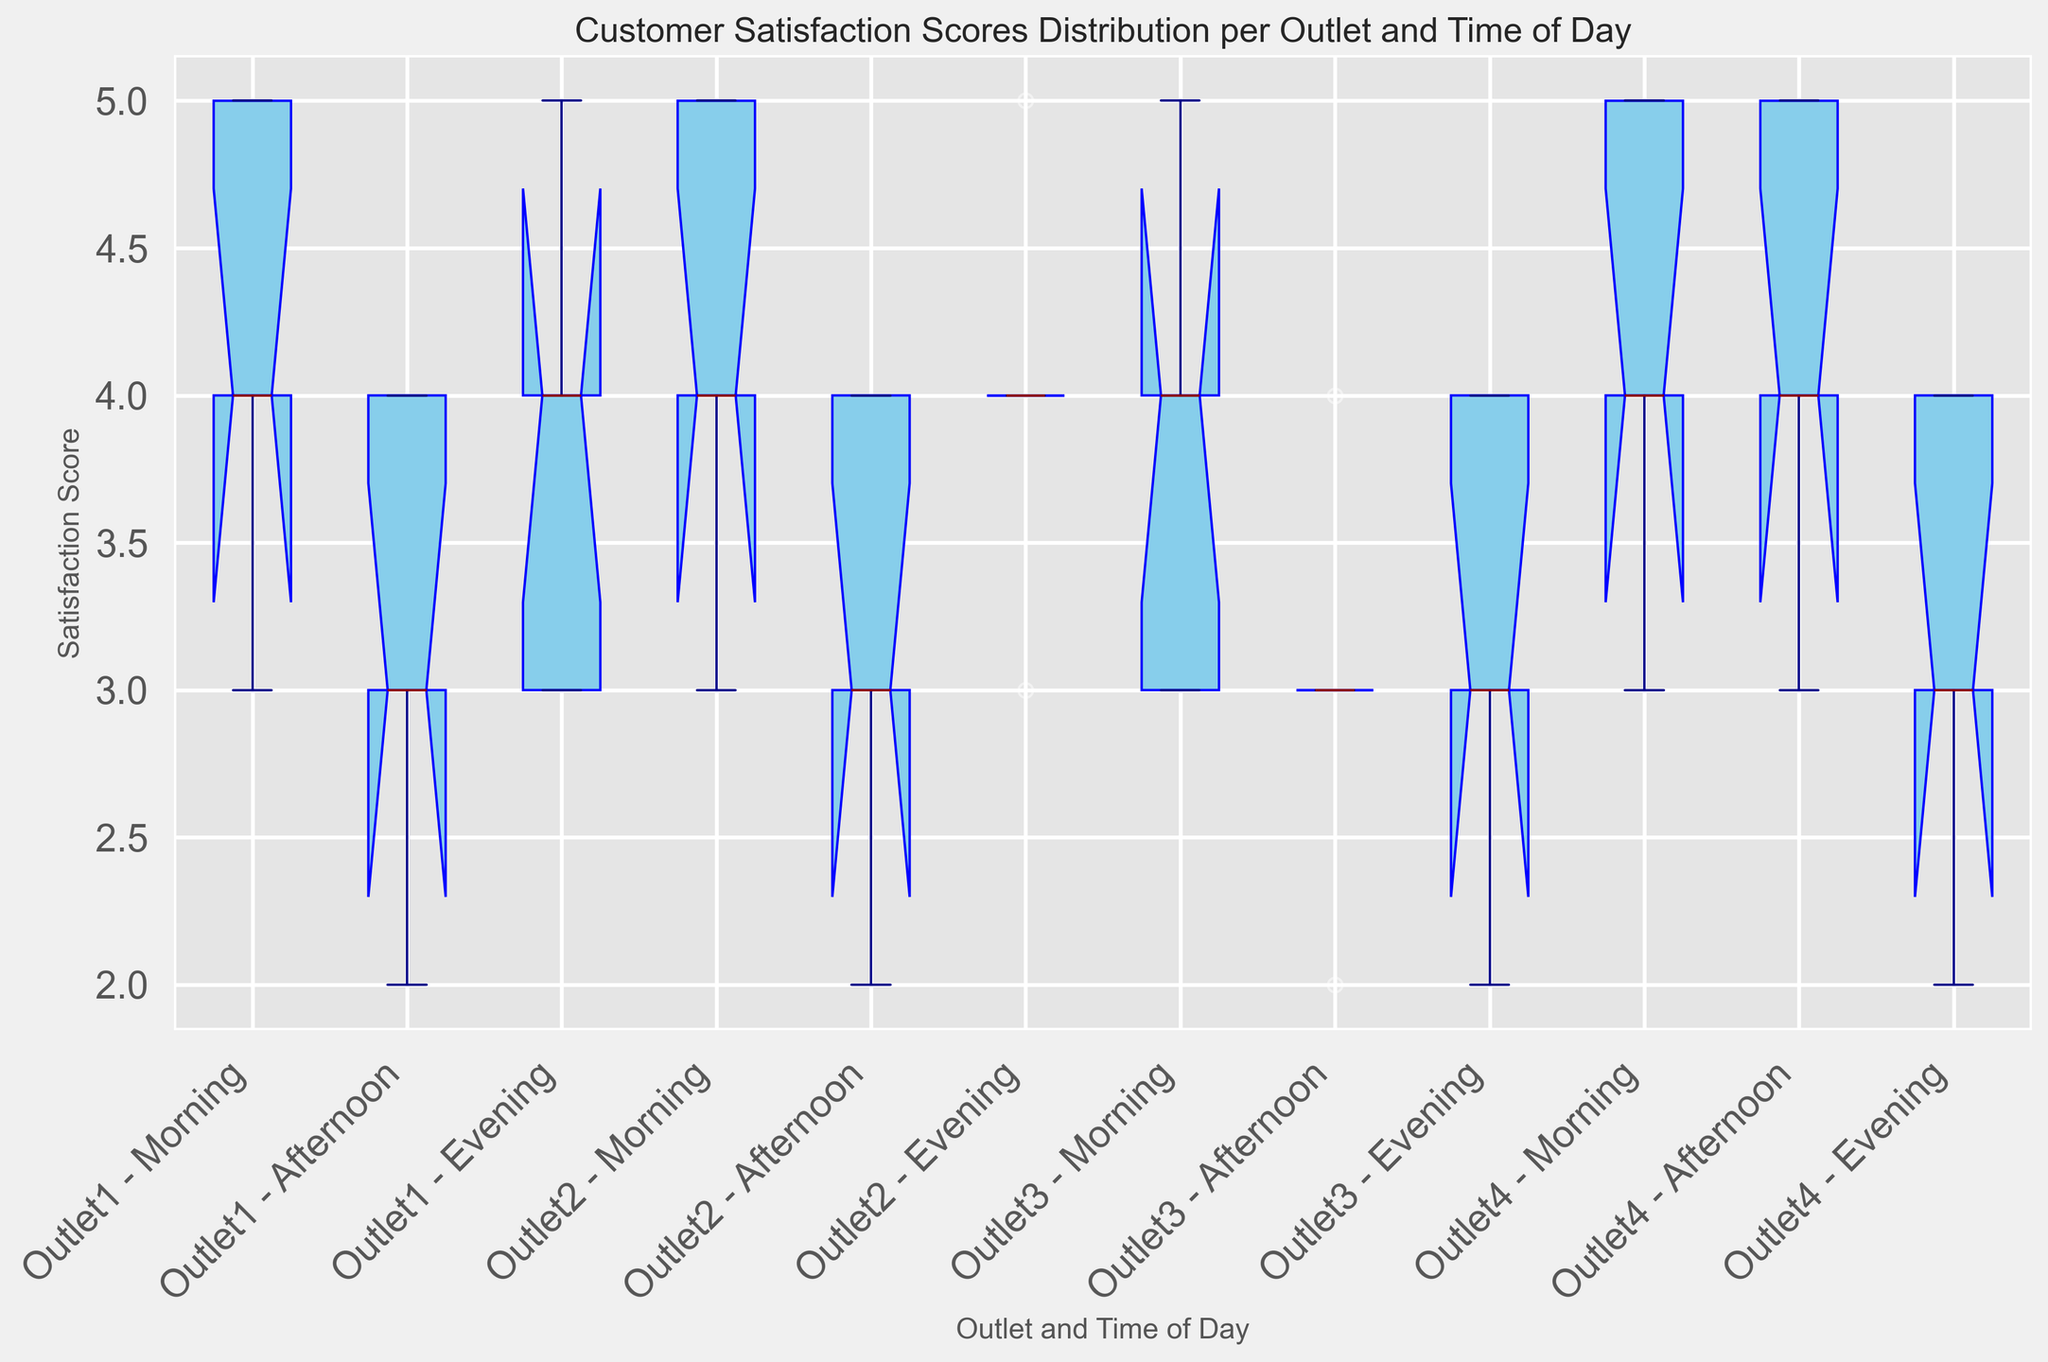What's the median customer satisfaction score for Outlet1 in the morning? To find the median, list the scores: [3, 4, 4, 5, 5]. The middle value is the third score, which is 4.
Answer: 4 Which time of day has the widest range of customer satisfaction scores for Outlet4? Compare the range (difference between maximum and minimum scores) for Morning [3, 5] (range 2), Afternoon [3, 5] (range 2), Evening [2, 4] (range 2). They all have the same range of 2.
Answer: All Equal Which outlet has the highest median satisfaction score in the Afternoon? Determine the median for each outlet in the Afternoon: Outlet1 [2, 3, 3, 4, 4] median is 3; Outlet2 [2, 3, 3, 4, 4] median is 3; Outlet3 [2, 3, 3, 3, 4] median is 3; Outlet4 [3, 4, 4, 5, 5] median is 4. Outlet4 has the highest median.
Answer: Outlet4 In the Evening, which outlet has the smallest interquartile range (IQR) of customer satisfaction scores? Calculate the IQR for each outlet in the Evening: Outlet1 [3, 3, 4, 4, 5] IQR is 1 (quartiles are Q1=3, Q3=4); Outlet2 [3, 4, 4, 4, 5] IQR is 1( Q1=4, Q3=4); Outlet3 [2, 3, 3, 4, 4] IQR is 1 (Quartiles Q1=3, Q3=4); Outlet4 [2, 3, 3, 4, 4]  IQR is 1(Quartiles Q1=3, Q3=4); IQR is smallest for all outlets.
Answer: All Equal For Outlet2, which time of day shows the least variability in customer satisfaction scores? Variability of scores is determined by the range: Morning [3, 4, 4, 5, 5] (range 2), Afternoon [2, 3, 3, 4, 4] (range 2), Evening [3, 4, 4, 4, 5] (range 2). All have the same range.
Answer: All Equal Compare the overall median satisfaction scores among outlets. Which outlet has the highest median score across all times of day? Determine the overall median for each outlet by combining all times of day: Outlet1 [2, 3, 3, 3, 4, 4, 4, 4, 4, 5, 5, 5] median is 4; Outlet2 [2, 3, 3, 3, 4, 4, 4, 4, 4, 5, 5, 5] median is 4; Outlet3 [2, 3, 3, 3, 4, 4, 4, 4, 5] median is 4; Outlet4 [2, 3, 3, 3, 4, 4, 4, 5, 5] median is 4. All outlets have the same median score.
Answer: All Equal Which outlet shows the highest maximum customer satisfaction score in the Evening? Compare the maximum scores in the Evening: Outlet1 [5], Outlet2 [5], Outlet3 [4], Outlet4 [4]. Outlet1 and Outlet2 have the highest maximum scores.
Answer: Outlet1 and Outlet2 In the Morning, which outlet has the lowest minimum satisfaction score? Compare the minimum scores in the Morning: Outlet1 [3], Outlet2 [3], Outlet3 [3], Outlet4 [3]. All have the same minimum score.
Answer: All Equal What is the difference between the highest median satisfaction score and the lowest median satisfaction score in the Evening? Determine the medians in the Evening for each outlet: Outlet1 [4], Outlet2 [4], Outlet3 [3], Outlet4 [3]. The difference is 4 - 3 = 1.
Answer: 1 